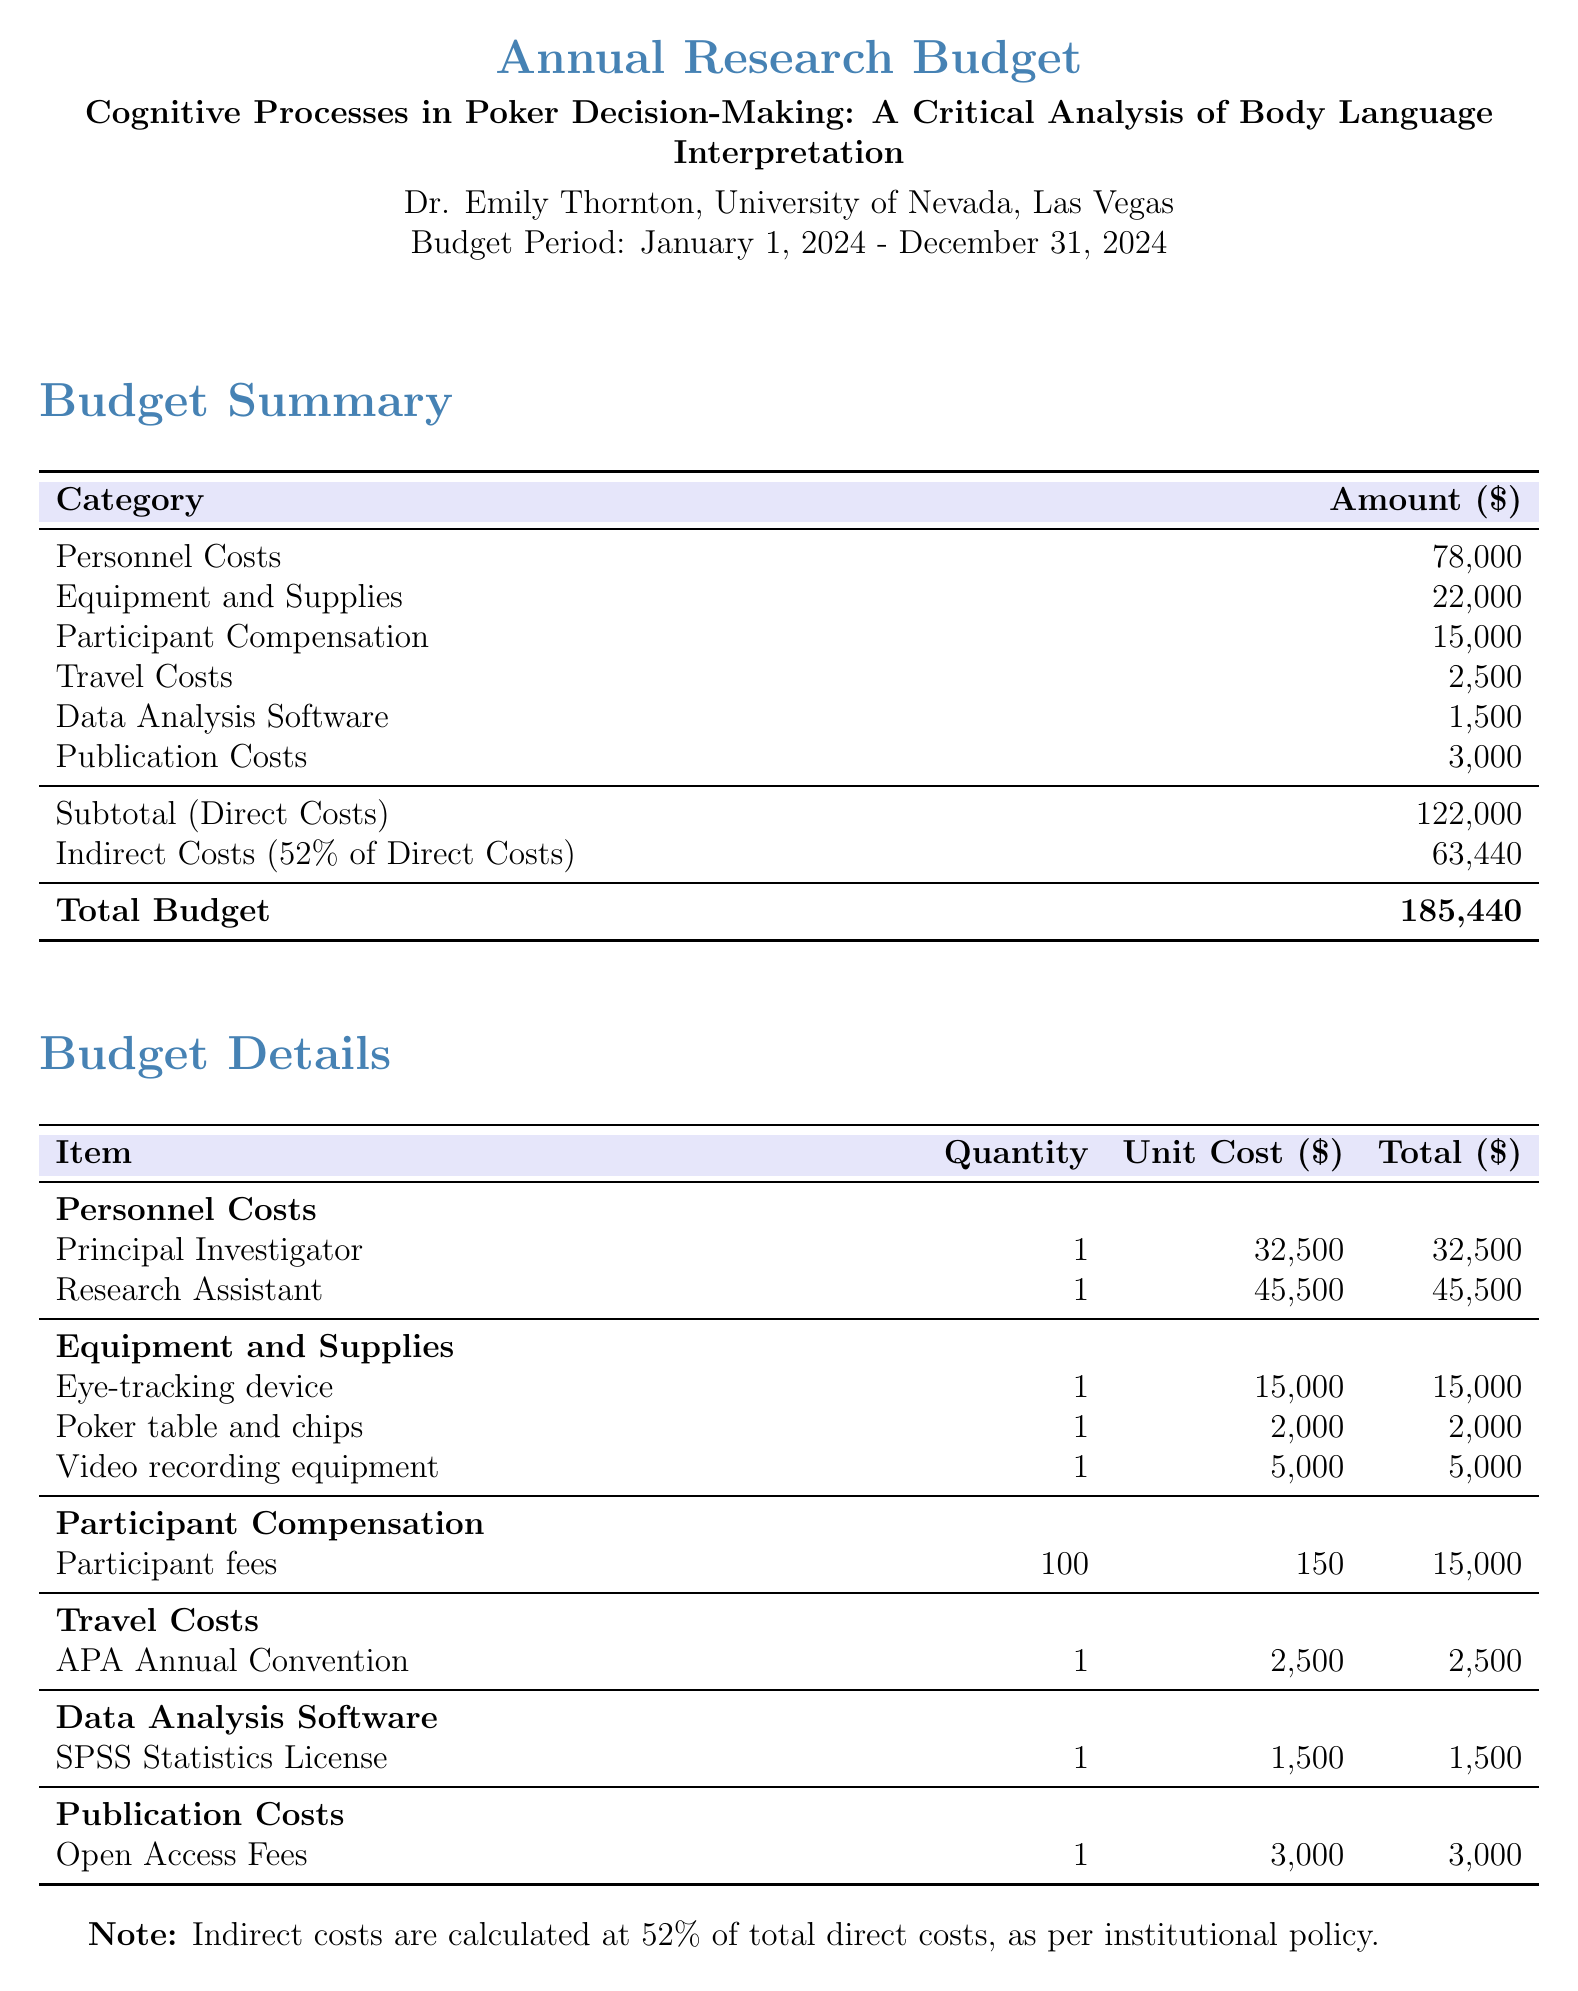What is the total budget? The total budget is clearly stated at the bottom of the budget summary section.
Answer: 185,440 Who is the principal investigator? The name of the principal investigator is mentioned in the title section of the document.
Answer: Dr. Emily Thornton What percentage are indirect costs of direct costs? The indirect costs are calculated as a percentage of total direct costs, which is indicated in the document.
Answer: 52% How much is allocated for participant compensation? The budget details section specifies the amount dedicated to participant compensation.
Answer: 15,000 What is the cost of the eye-tracking device? The cost of the eye-tracking device is listed in the equipment and supplies section of the budget details.
Answer: 15,000 What event is covered under travel costs? The document mentions a specific event related to travel costs in the budget details section.
Answer: APA Annual Convention How many research assistants are budgeted? The quantity of research assistants is specified in the personnel costs section of the budget details.
Answer: 1 What are the publication costs? The publication costs are explicitly detailed in the budget, showing the specific cost allocated for this purpose.
Answer: 3,000 What is the total for direct costs? The total for direct costs is calculated based on the sum of various categories listed in the budget summary.
Answer: 122,000 